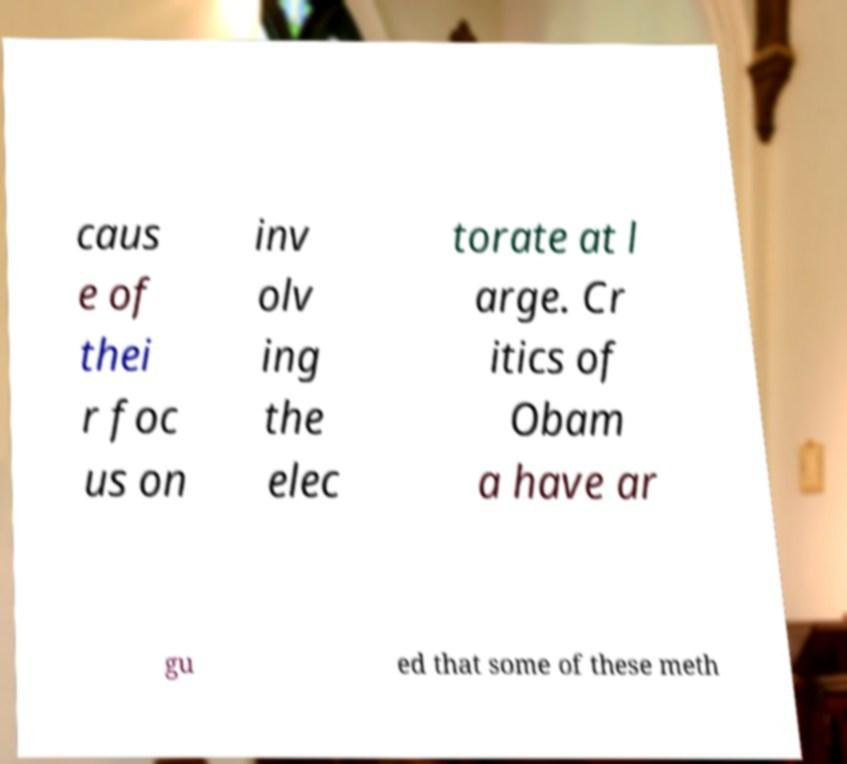There's text embedded in this image that I need extracted. Can you transcribe it verbatim? caus e of thei r foc us on inv olv ing the elec torate at l arge. Cr itics of Obam a have ar gu ed that some of these meth 